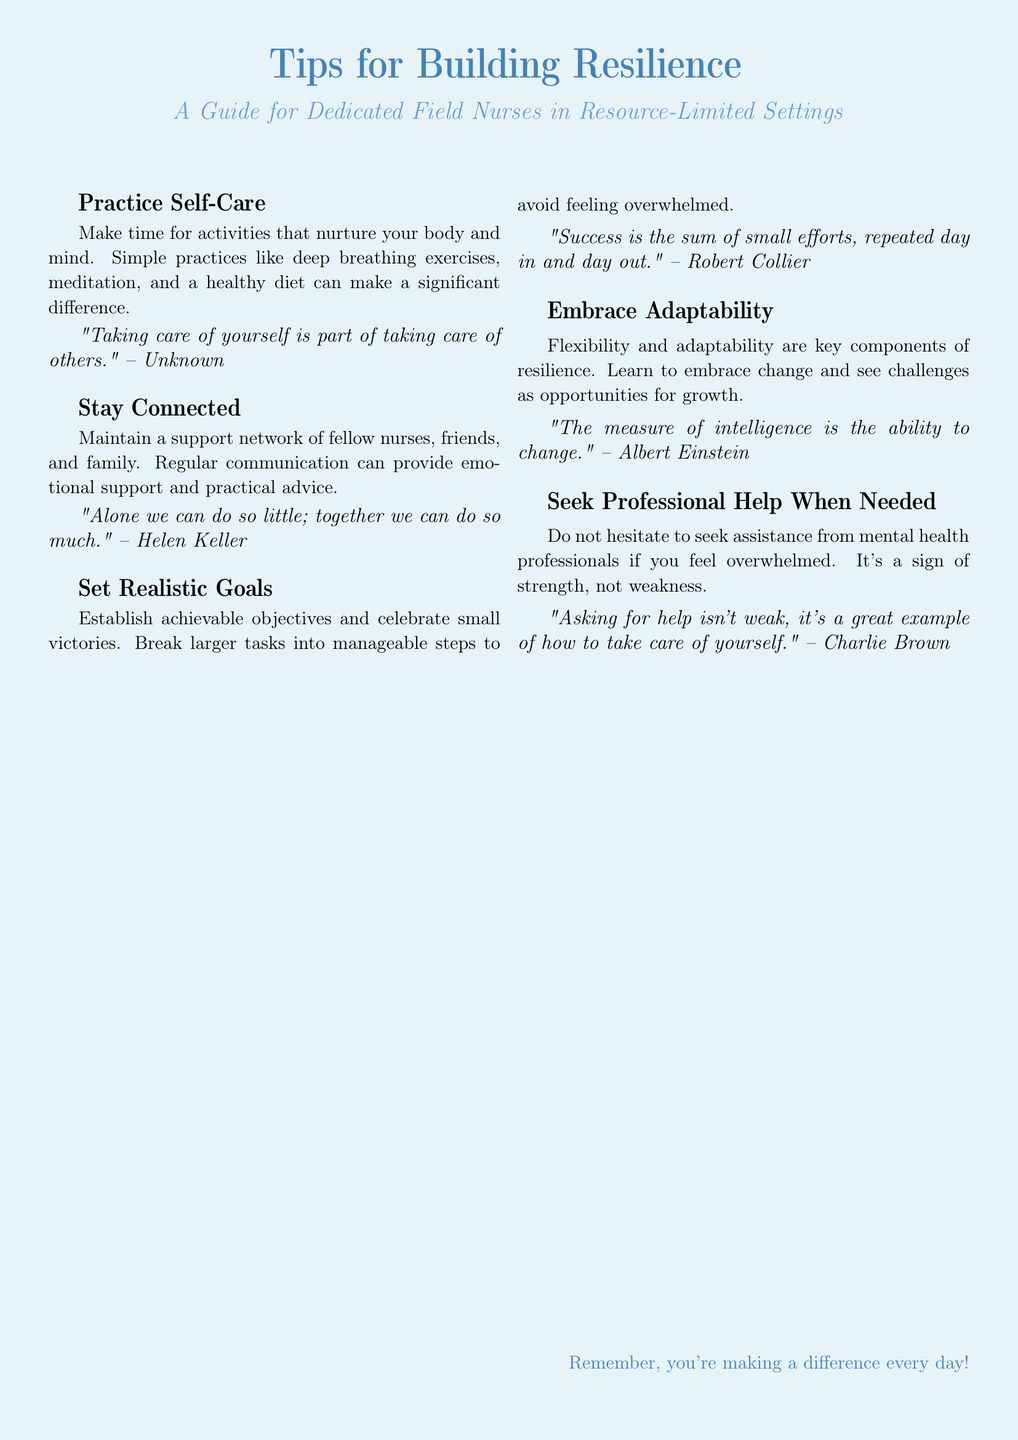what is the main title of the card? The main title is prominently displayed at the top of the document.
Answer: Tips for Building Resilience how many tips are provided in the card? There are five different tips listed on the card.
Answer: 5 what is the first tip mentioned? The first tip is the initial piece of advice given in the document.
Answer: Practice Self-Care who is quoted in the tip about staying connected? The quote provided supports the importance of connection and is attributed to a famous individual.
Answer: Helen Keller what does the tip about seeking professional help emphasize? This tip highlights the importance of reaching out for assistance when feeling overwhelmed.
Answer: Strength which color is used for the title text? The title text uses a specific shade defined within the document's colors.
Answer: Nurseblue what is the purpose of the card? The overall intent of the document is clear from the introduction and themes throughout.
Answer: Guidance for dedicated field nurses what does the last phrase encourage? The concluding phrase provides motivation related to the impact of the nurses' work.
Answer: Making a difference every day what is the recommended approach to challenges according to the card? This advice summarizes how resilience can be built through certain attitudes.
Answer: Embrace Adaptability 